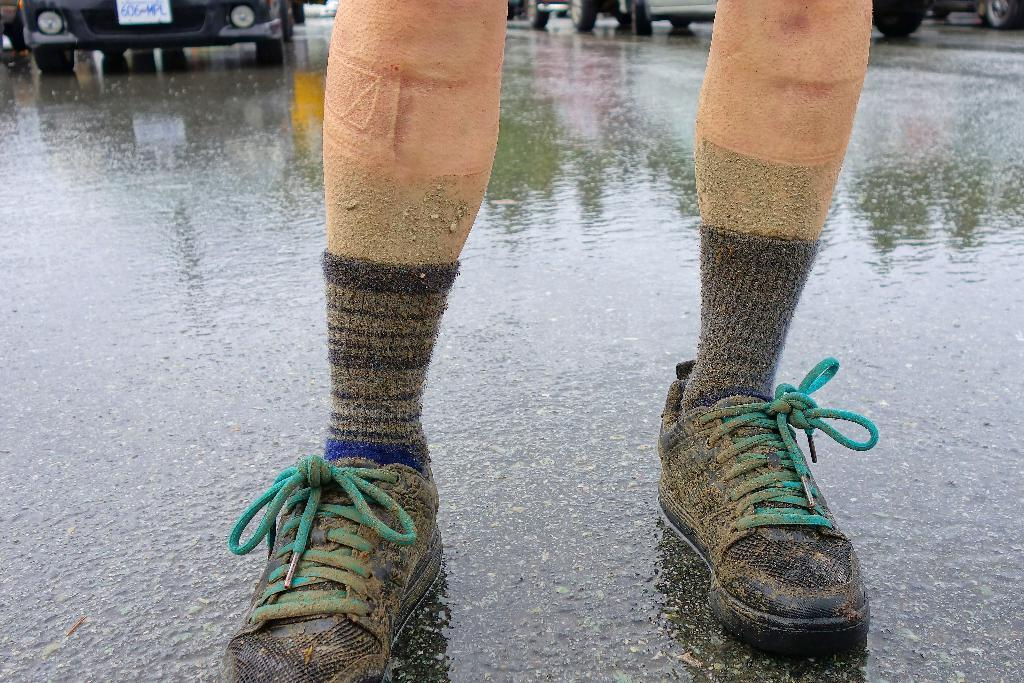What can be seen in the image related to people? There are persons' legs visible in the image. What is happening in the image related to transportation? There are vehicles on the road in the image. What type of badge is being worn by the person in the image? There is no person visible in the image, only legs, so it is not possible to determine if they are wearing a badge. 